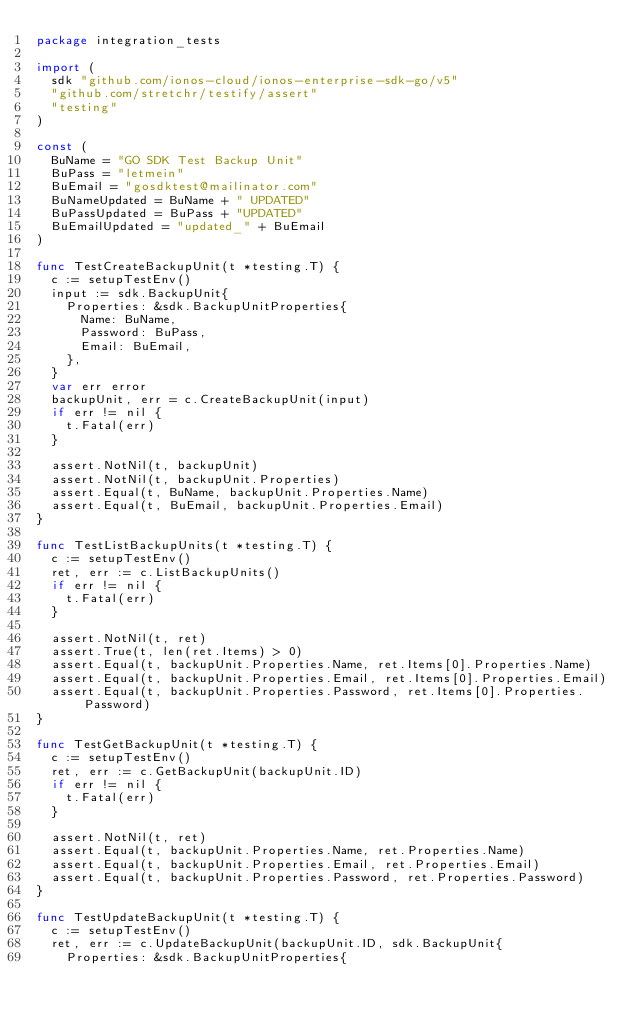Convert code to text. <code><loc_0><loc_0><loc_500><loc_500><_Go_>package integration_tests

import (
	sdk "github.com/ionos-cloud/ionos-enterprise-sdk-go/v5"
	"github.com/stretchr/testify/assert"
	"testing"
)

const (
	BuName = "GO SDK Test Backup Unit"
	BuPass = "letmein"
	BuEmail = "gosdktest@mailinator.com"
	BuNameUpdated = BuName + " UPDATED"
	BuPassUpdated = BuPass + "UPDATED"
	BuEmailUpdated = "updated_" + BuEmail
)

func TestCreateBackupUnit(t *testing.T) {
	c := setupTestEnv()
	input := sdk.BackupUnit{
		Properties: &sdk.BackupUnitProperties{
			Name: BuName,
			Password: BuPass,
			Email: BuEmail,
		},
	}
	var err error
	backupUnit, err = c.CreateBackupUnit(input)
	if err != nil {
		t.Fatal(err)
	}

	assert.NotNil(t, backupUnit)
	assert.NotNil(t, backupUnit.Properties)
	assert.Equal(t, BuName, backupUnit.Properties.Name)
	assert.Equal(t, BuEmail, backupUnit.Properties.Email)
}

func TestListBackupUnits(t *testing.T) {
	c := setupTestEnv()
	ret, err := c.ListBackupUnits()
	if err != nil {
		t.Fatal(err)
	}

	assert.NotNil(t, ret)
	assert.True(t, len(ret.Items) > 0)
	assert.Equal(t, backupUnit.Properties.Name, ret.Items[0].Properties.Name)
	assert.Equal(t, backupUnit.Properties.Email, ret.Items[0].Properties.Email)
	assert.Equal(t, backupUnit.Properties.Password, ret.Items[0].Properties.Password)
}

func TestGetBackupUnit(t *testing.T) {
	c := setupTestEnv()
	ret, err := c.GetBackupUnit(backupUnit.ID)
	if err != nil {
		t.Fatal(err)
	}

	assert.NotNil(t, ret)
	assert.Equal(t, backupUnit.Properties.Name, ret.Properties.Name)
	assert.Equal(t, backupUnit.Properties.Email, ret.Properties.Email)
	assert.Equal(t, backupUnit.Properties.Password, ret.Properties.Password)
}

func TestUpdateBackupUnit(t *testing.T) {
	c := setupTestEnv()
	ret, err := c.UpdateBackupUnit(backupUnit.ID, sdk.BackupUnit{
		Properties: &sdk.BackupUnitProperties{</code> 